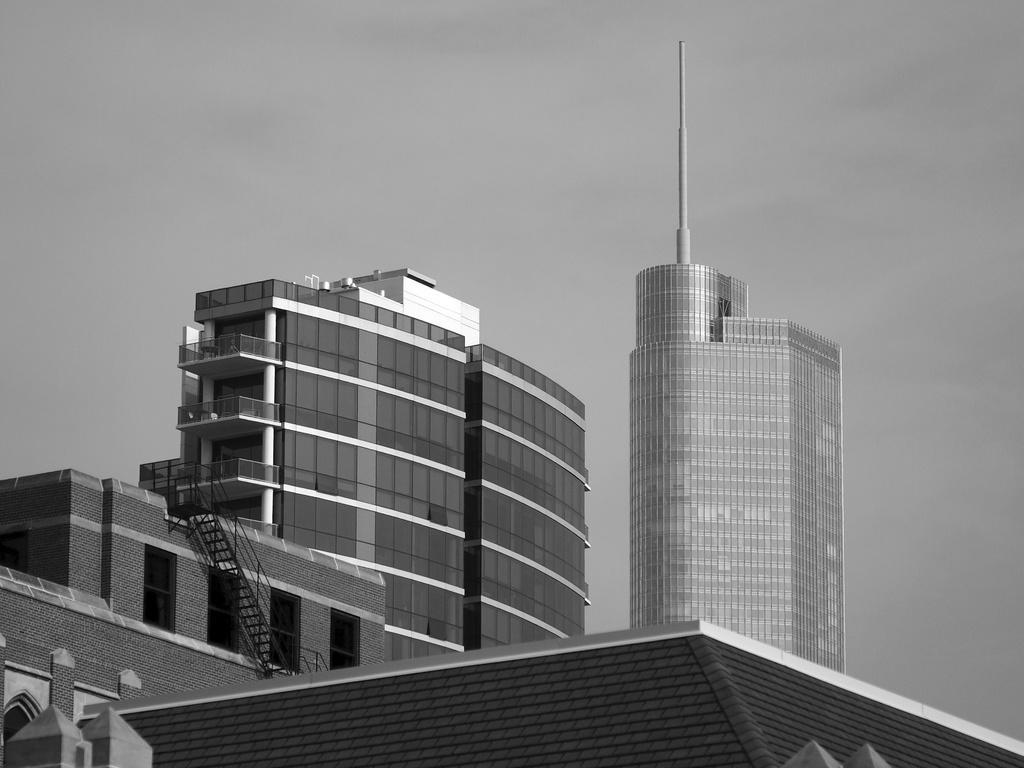Could you give a brief overview of what you see in this image? In this picture there are buildings. On the left side of the image there is a staircase. In the foreground it looks like roof tiles on the top of the building. At the top there is sky. 